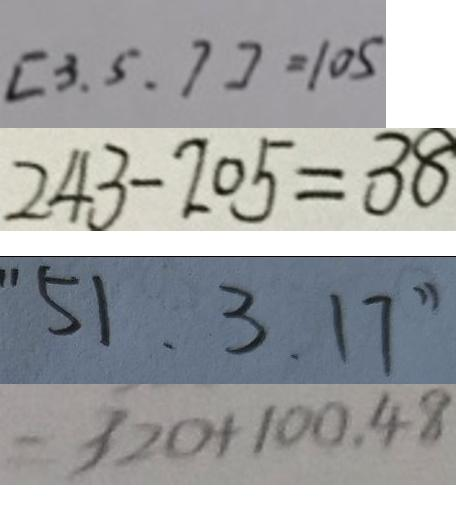Convert formula to latex. <formula><loc_0><loc_0><loc_500><loc_500>[ 3 . 5 . 7 ] = 1 0 5 
 2 4 3 - 2 0 5 = 3 8 
 " 5 1 . 3 . 1 7 " 
 = 3 2 0 + 1 0 0 . 4 8</formula> 